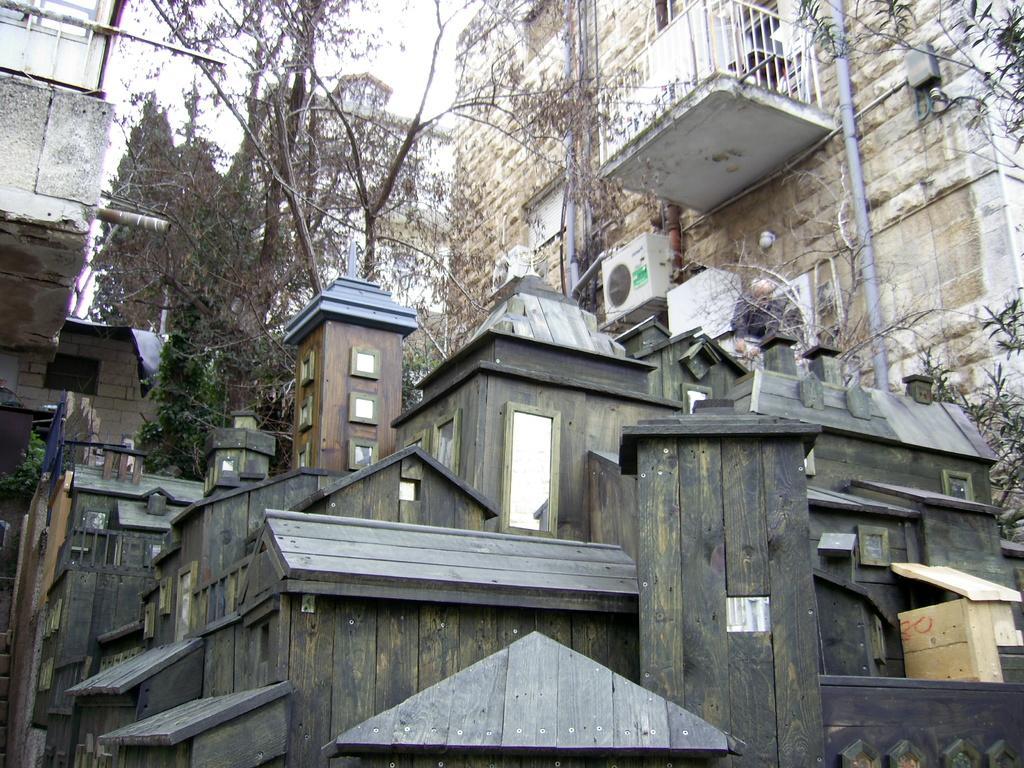In one or two sentences, can you explain what this image depicts? In the center of the image there is a wooden house. In the background of the image there are buildings,trees. 